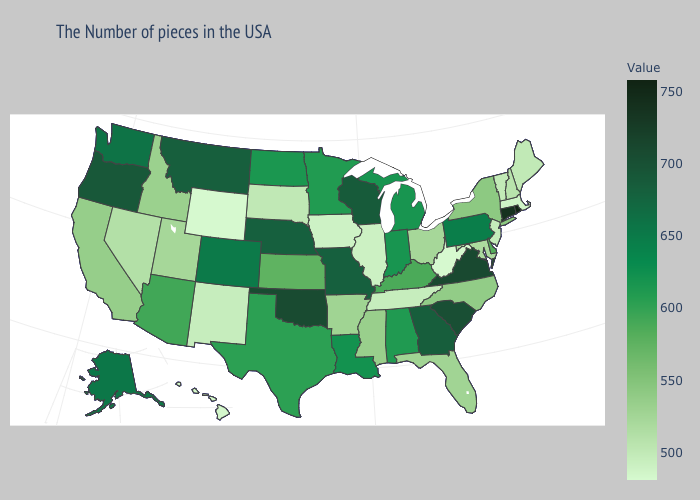Does Maryland have the lowest value in the South?
Keep it brief. No. Does Rhode Island have the lowest value in the Northeast?
Be succinct. No. Among the states that border Vermont , which have the highest value?
Quick response, please. New York. Is the legend a continuous bar?
Answer briefly. Yes. Among the states that border Massachusetts , does Vermont have the lowest value?
Short answer required. Yes. Which states have the lowest value in the USA?
Give a very brief answer. West Virginia, Wyoming. 